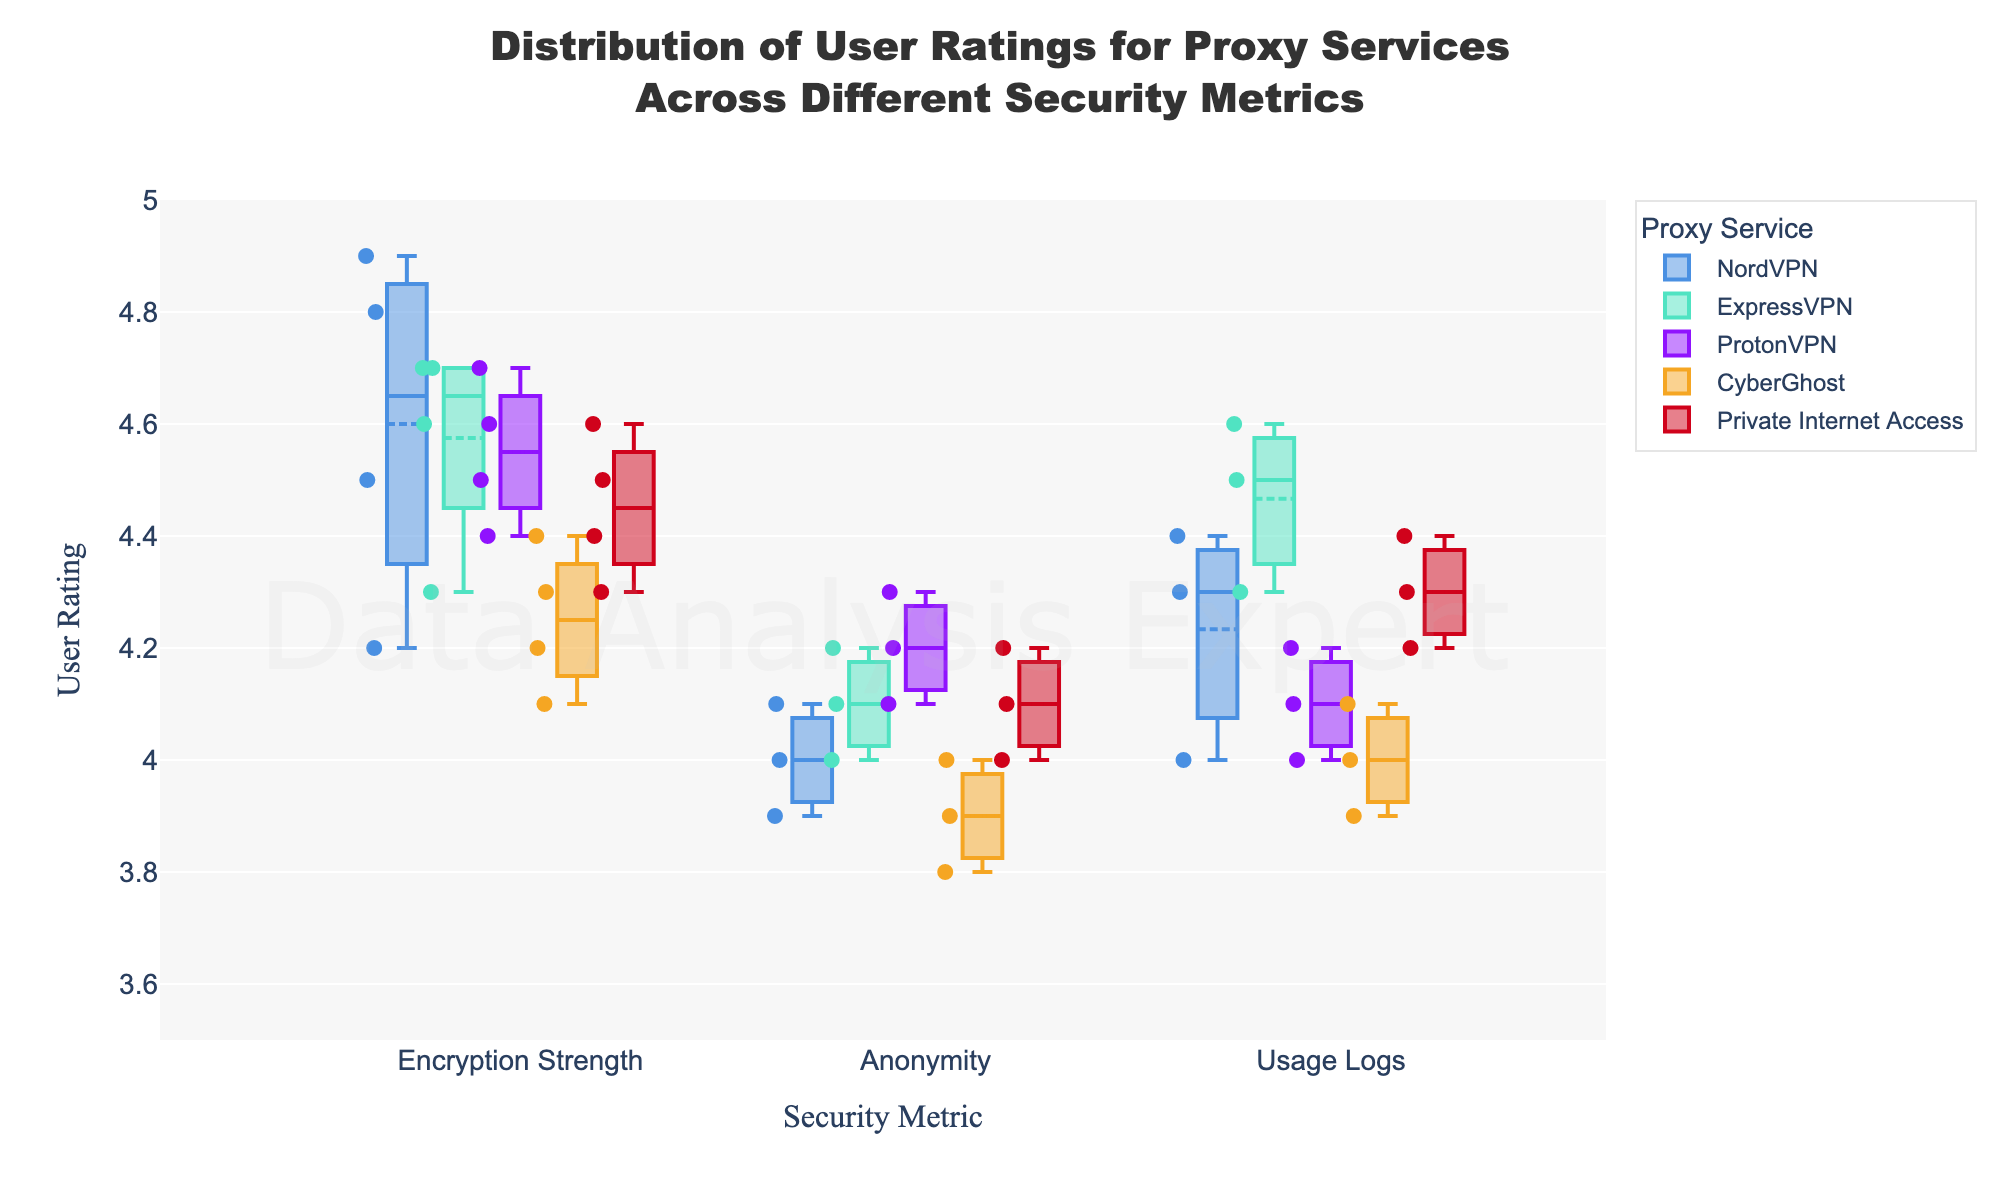What is the title of the plot? The title of the plot is located at the top center of the figure. It describes what the plot represents.
Answer: Distribution of User Ratings for Proxy Services Across Different Security Metrics Which security metric has the highest median user rating for NordVPN? To find the highest median user rating for NordVPN, locate the NordVPN sections for each security metric (Encryption Strength, Anonymity, Usage Logs), and identify which box has the highest median line.
Answer: Encryption Strength Comparing NordVPN and ExpressVPN, which service has a higher average user rating for Encryption Strength? To compare these services, look at the mean marker in the boxes for Encryption Strength for both NordVPN and ExpressVPN. Identify which one is higher.
Answer: ExpressVPN What is the color used to represent ProtonVPN? The color of each service is represented in the legend. Find ProtonVPN in the legend to see its color.
Answer: Purple How many distinct security metrics are evaluated in the plot? The distinct security metrics can be identified along the x-axis labels. Count the different labels present.
Answer: Three Which service has the lowest minimum user rating for the Anonymity metric? Look at the minimum whisker values in the Anonymity sections of the box plots for each service and find the lowest one.
Answer: NordVPN Compare the spreads of user ratings for Encryption Strength for ProtonVPN and CyberGhost. Which one has a narrower spread? The spread is indicated by the length of the box and whiskers. Compare the lengths of the boxes and whiskers in the Encryption Strength sections for ProtonVPN and CyberGhost.
Answer: ProtonVPN What is the highest user rating recorded for Usage Logs across any service? The highest user rating recorded is the topmost point in the Usage Logs section for all services.
Answer: 4.6 Which service's user ratings for Usage Logs are most concentrated around the median? Look for the service whose box (interquartile range) is smallest around the median in the Usage Logs section.
Answer: ProtonVPN What is the common range of user ratings for Private Internet Access across all metrics? Identify the lowest and highest whiskers across all metrics for Private Internet Access.
Answer: 4.0 to 4.6 